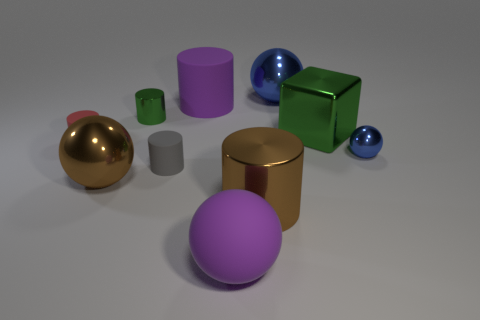Do the large blue shiny object and the large purple object that is in front of the brown cylinder have the same shape?
Keep it short and to the point. Yes. Is the number of large purple matte cylinders to the right of the brown cylinder less than the number of small shiny things that are in front of the green block?
Your response must be concise. Yes. What material is the other blue object that is the same shape as the large blue metal thing?
Your answer should be very brief. Metal. Does the big metallic block have the same color as the tiny shiny cylinder?
Provide a short and direct response. Yes. There is a tiny blue object that is made of the same material as the large brown cylinder; what shape is it?
Provide a short and direct response. Sphere. How many large blue objects have the same shape as the tiny green object?
Keep it short and to the point. 0. What shape is the blue metallic object behind the green object to the left of the large blue object?
Your answer should be compact. Sphere. There is a metal cylinder in front of the block; is it the same size as the tiny gray rubber cylinder?
Ensure brevity in your answer.  No. There is a shiny thing that is both in front of the small blue object and to the left of the small gray object; what size is it?
Offer a terse response. Large. What number of shiny spheres are the same size as the gray object?
Ensure brevity in your answer.  1. 